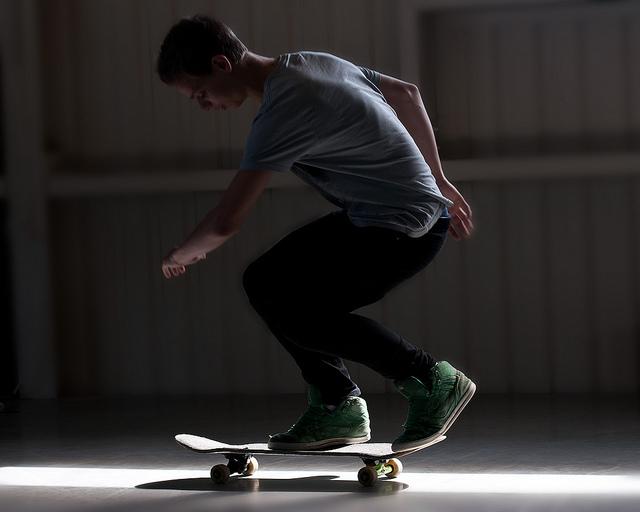Is the sport fun?
Keep it brief. Yes. What is cast?
Be succinct. Shadow. What is this person standing on?
Short answer required. Skateboard. 